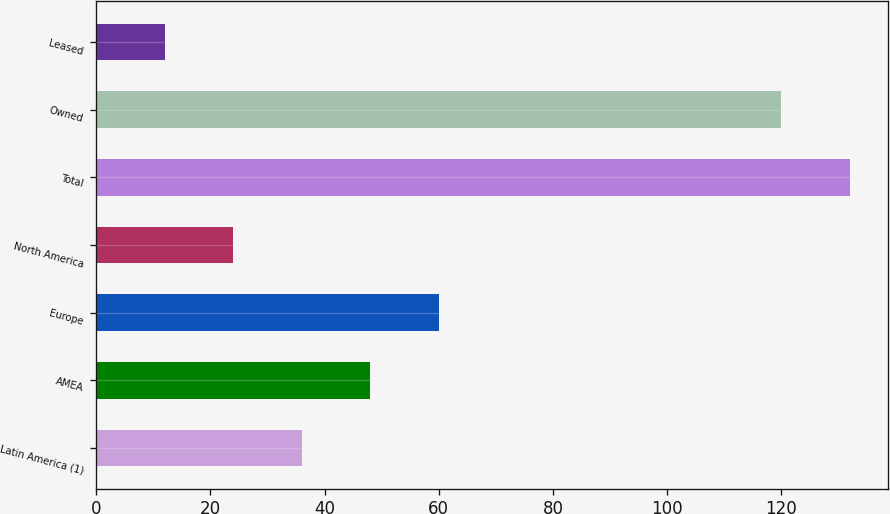Convert chart. <chart><loc_0><loc_0><loc_500><loc_500><bar_chart><fcel>Latin America (1)<fcel>AMEA<fcel>Europe<fcel>North America<fcel>Total<fcel>Owned<fcel>Leased<nl><fcel>36<fcel>48<fcel>60<fcel>24<fcel>132<fcel>120<fcel>12<nl></chart> 